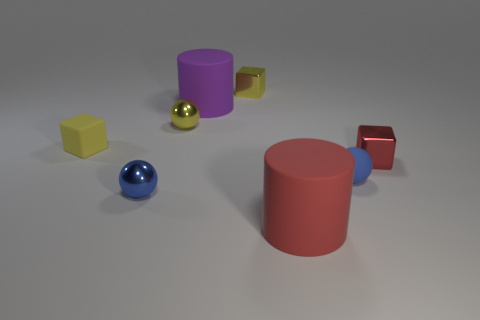Add 2 cyan shiny cubes. How many objects exist? 10 Subtract all spheres. How many objects are left? 5 Add 2 blue things. How many blue things are left? 4 Add 2 yellow spheres. How many yellow spheres exist? 3 Subtract 1 red blocks. How many objects are left? 7 Subtract all large blue metallic cylinders. Subtract all yellow shiny blocks. How many objects are left? 7 